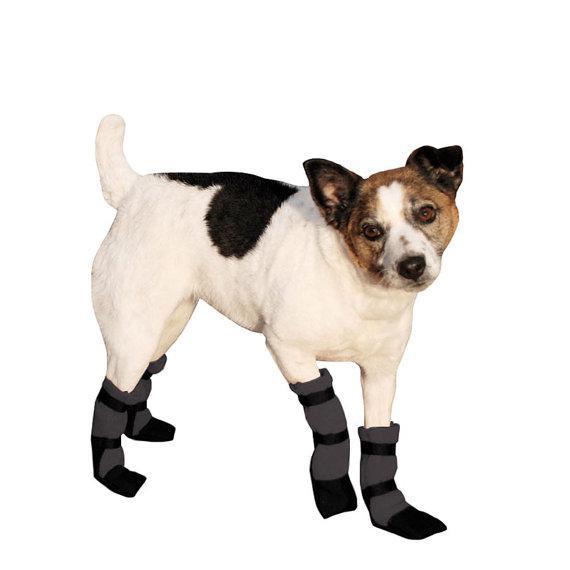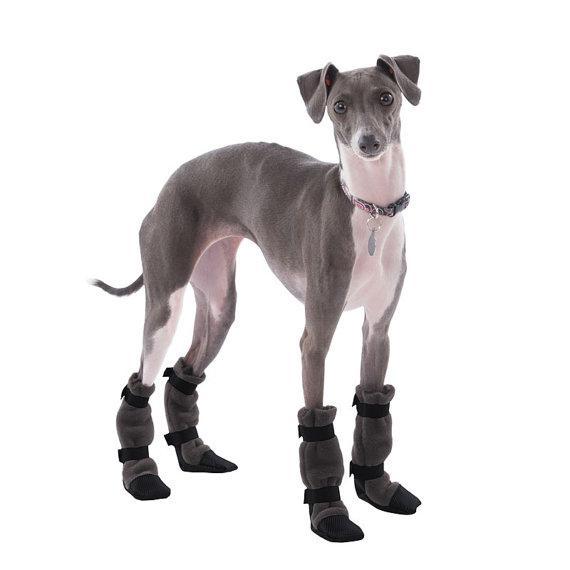The first image is the image on the left, the second image is the image on the right. Evaluate the accuracy of this statement regarding the images: "At least one of the dogs is wearing something on its feet.". Is it true? Answer yes or no. Yes. 